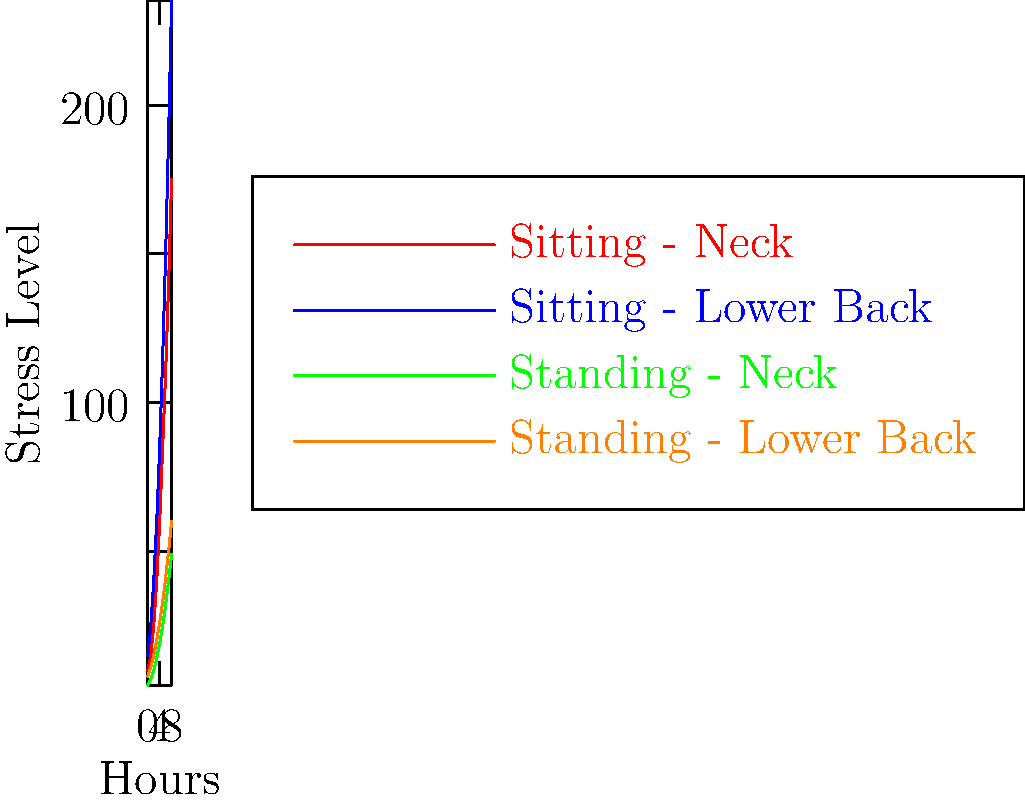Based on the graph showing stress levels on different body parts over time for sitting and standing desks, after how many hours does the stress level on the lower back while sitting exceed 100 units, and what potential impact might this have on employee productivity and workplace ergonomics? To answer this question, we need to analyze the graph and consider the implications for workplace ergonomics:

1. Identify the line representing sitting lower back stress (blue line).
2. Trace the blue line to find where it crosses the 100-unit stress level.
3. From the graph, we can see that the sitting lower back stress exceeds 100 units at approximately 6 hours.
4. Compare this to the standing desk data (orange line for lower back), which shows significantly lower stress levels over time.
5. Consider the impact on employee productivity:
   a. Higher stress levels may lead to discomfort and pain.
   b. Discomfort can result in decreased focus and productivity.
   c. Prolonged exposure to high stress levels may lead to long-term health issues.
6. Workplace ergonomics implications:
   a. Need for regular breaks or position changes for employees using sitting desks.
   b. Potential benefits of implementing standing desks or sit-stand workstations.
   c. Importance of ergonomic assessments and employee education on proper posture.
7. Compliance considerations:
   a. Potential workplace health and safety regulations related to ergonomics.
   b. Risk management for employee health and potential workers' compensation claims.

The data suggests that implementing a mix of sitting and standing options, or encouraging regular position changes, could help mitigate the biomechanical stress associated with prolonged sitting.
Answer: 6 hours; decreased productivity, increased health risks, need for ergonomic interventions 